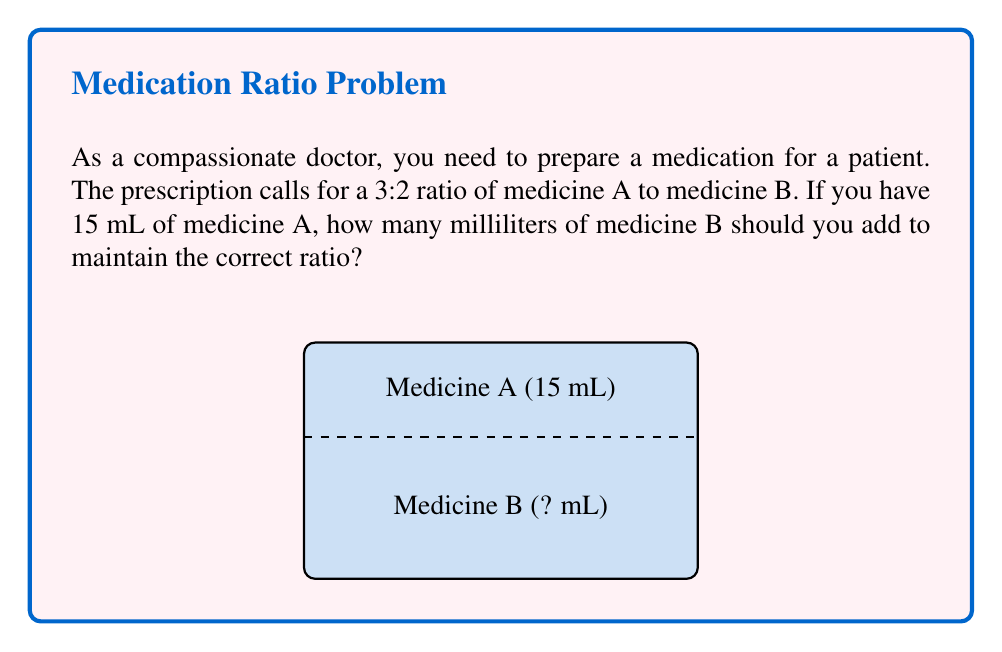What is the answer to this math problem? Let's approach this step-by-step:

1) The ratio of medicine A to medicine B is 3:2. This means for every 3 parts of medicine A, we need 2 parts of medicine B.

2) We can set up a proportion to solve this problem:

   $$\frac{\text{Medicine A}}{\text{Medicine B}} = \frac{3}{2}$$

3) We know we have 15 mL of medicine A. Let's call the amount of medicine B we need $x$ mL. We can now write:

   $$\frac{15}{x} = \frac{3}{2}$$

4) To solve for $x$, we can cross-multiply:

   $$15 \cdot 2 = 3x$$

5) Simplify:

   $$30 = 3x$$

6) Divide both sides by 3:

   $$\frac{30}{3} = x$$

7) Simplify:

   $$10 = x$$

Therefore, we need 10 mL of medicine B to maintain the correct 3:2 ratio with 15 mL of medicine A.
Answer: 10 mL 